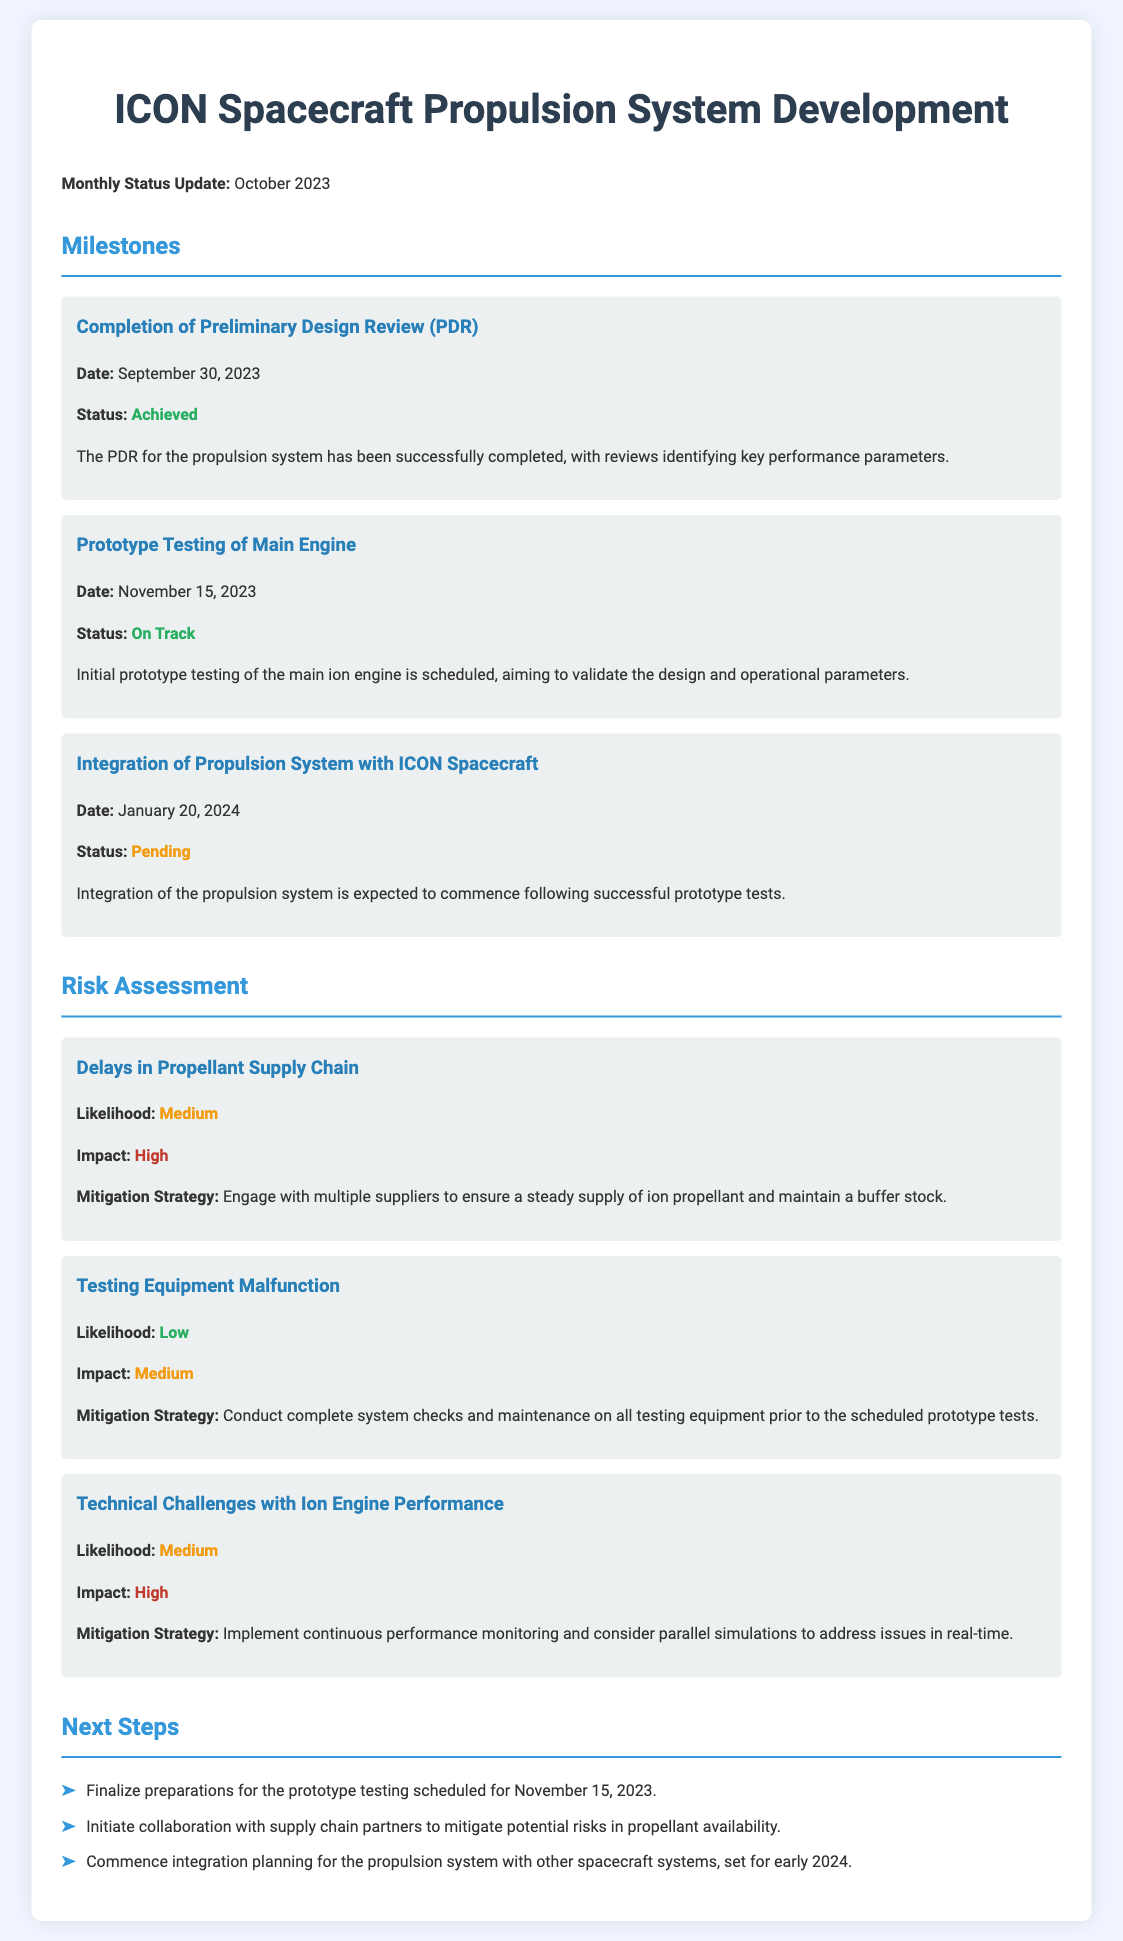what is the date of the Preliminary Design Review (PDR)? The date for the PDR milestone is clearly stated as September 30, 2023.
Answer: September 30, 2023 what is the status of the Prototype Testing of Main Engine? The status is mentioned in the document as "On Track."
Answer: On Track what is the impact level of the risk related to Delays in Propellant Supply Chain? The document indicates that the impact of this risk is classified as "High."
Answer: High when is the Integration of Propulsion System with ICON Spacecraft expected to begin? The expected date for this integration milestone is January 20, 2024, as mentioned in the document.
Answer: January 20, 2024 what is the likelihood classification for Technical Challenges with Ion Engine Performance? The document specifies that the likelihood of this risk is rated as "Medium."
Answer: Medium what is the mitigation strategy for Testing Equipment Malfunction? The document details that the strategy includes complete system checks and maintenance.
Answer: Conduct complete system checks and maintenance what are the next steps mentioned in the document? The next steps include finalizing preparations for prototype testing, collaborating on propellant availability risks, and commencing integration planning.
Answer: Finalize preparations for the prototype testing scheduled for November 15, 2023 what is the status of the Integration of Propulsion System with ICON Spacecraft? The status is noted as "Pending" in the document.
Answer: Pending 